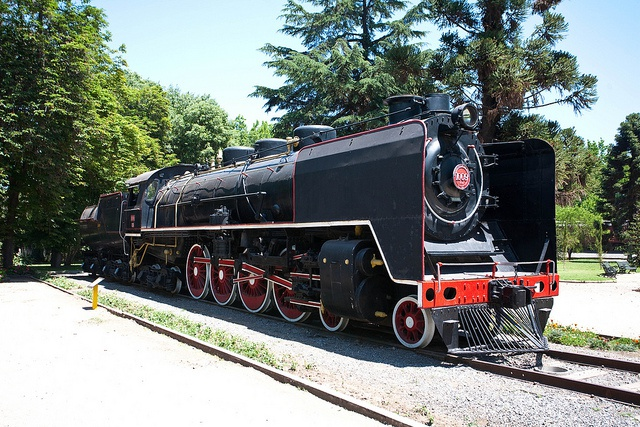Describe the objects in this image and their specific colors. I can see a train in black, gray, darkgray, and lightgray tones in this image. 